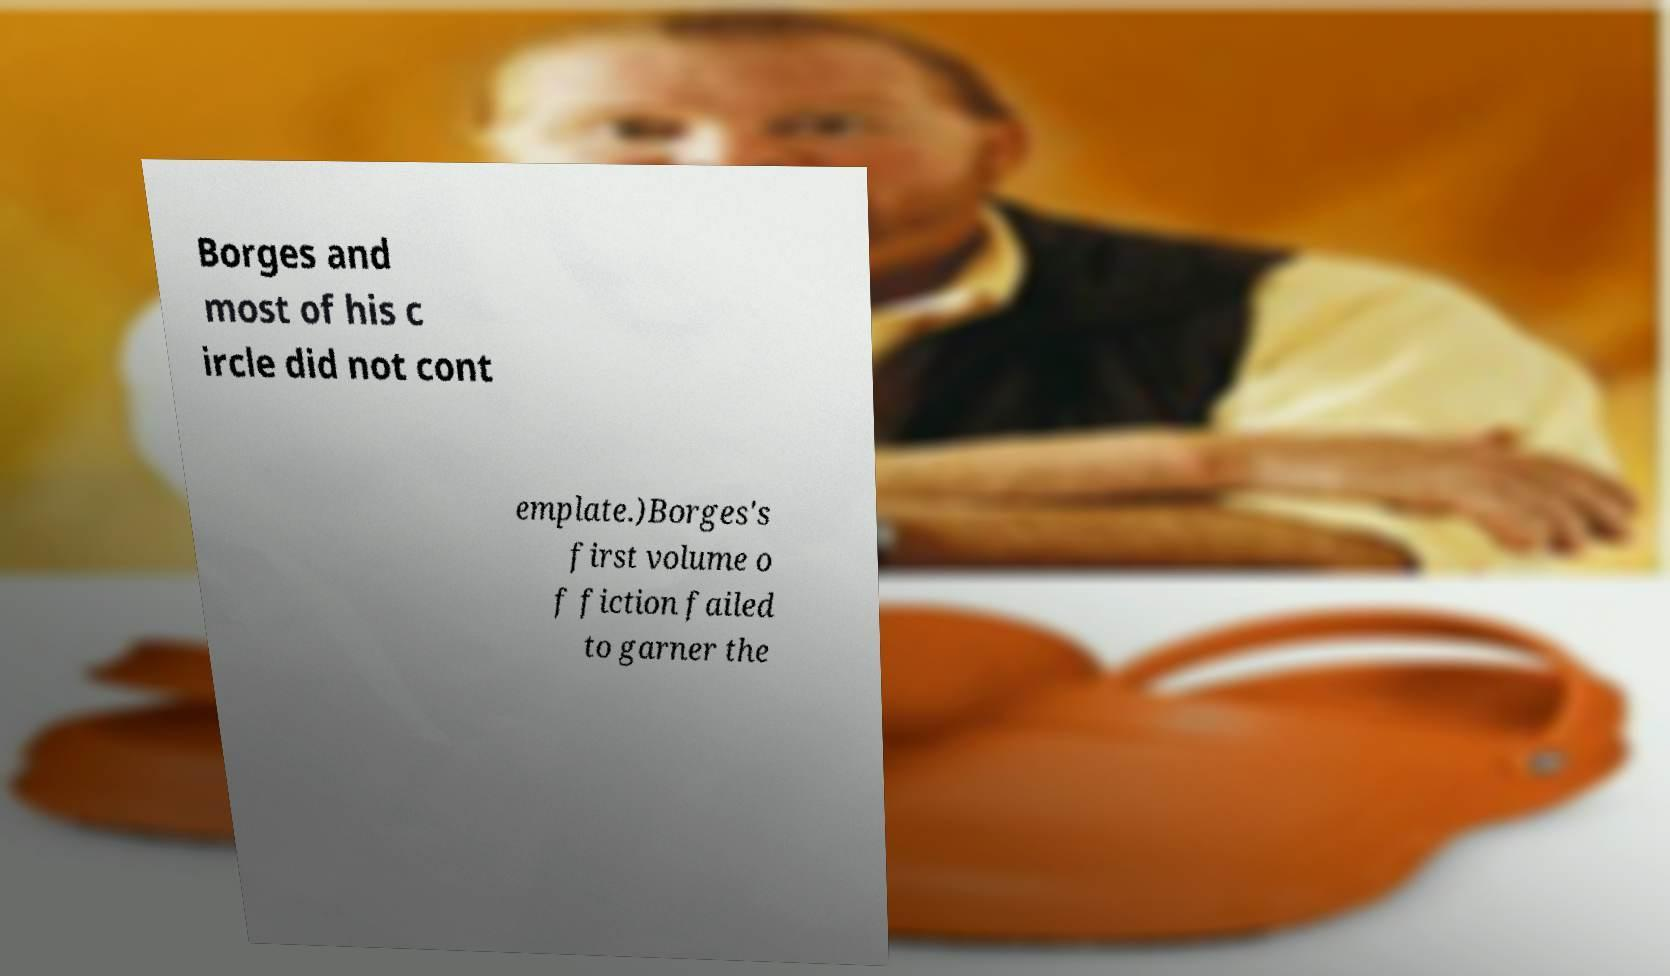Could you extract and type out the text from this image? Borges and most of his c ircle did not cont emplate.)Borges's first volume o f fiction failed to garner the 